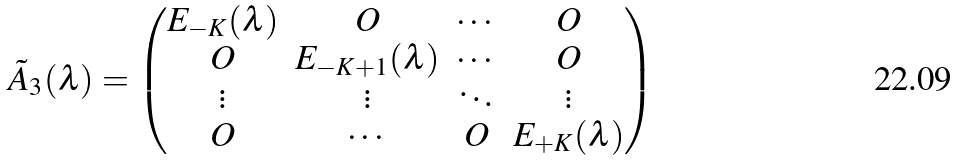<formula> <loc_0><loc_0><loc_500><loc_500>\tilde { A } _ { 3 } ( \lambda ) = \begin{pmatrix} E _ { - K } ( \lambda ) & O & \cdots & O \\ O & E _ { - K + 1 } ( \lambda ) & \cdots & O \\ \vdots & \vdots & \ddots & \vdots \\ O & \cdots & O & E _ { + K } ( \lambda ) \end{pmatrix}</formula> 